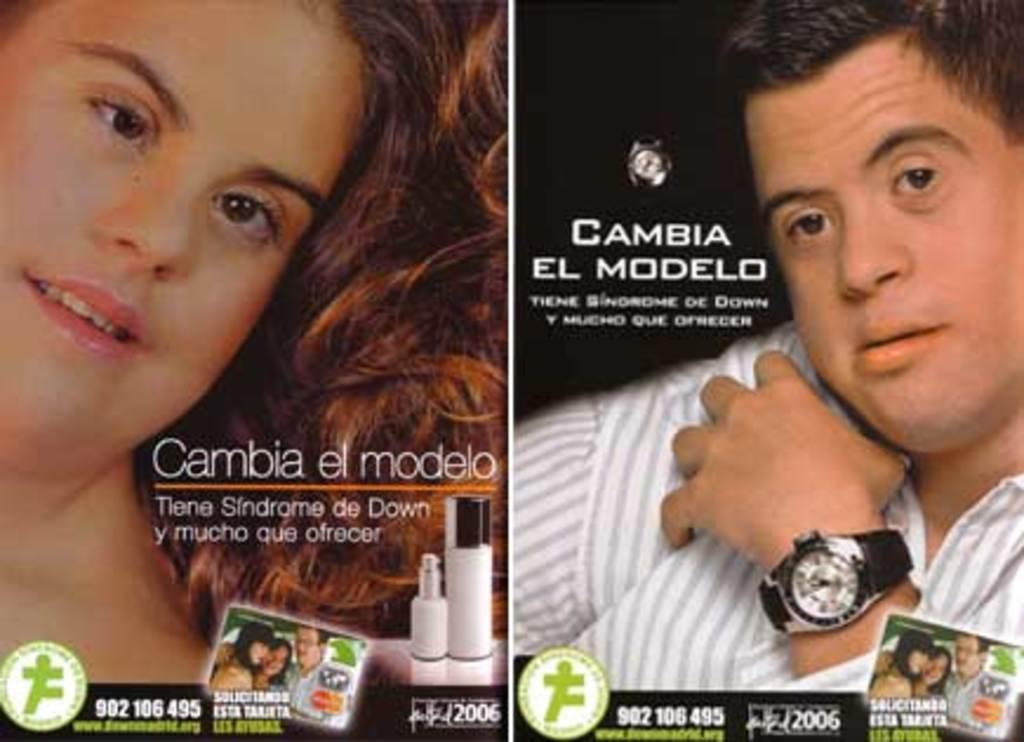<image>
Describe the image concisely. Two ads tell us that people with Down's Syndrome have much to offer. 